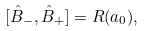<formula> <loc_0><loc_0><loc_500><loc_500>[ \hat { B } _ { - } , \hat { B } _ { + } ] = R ( a _ { 0 } ) ,</formula> 